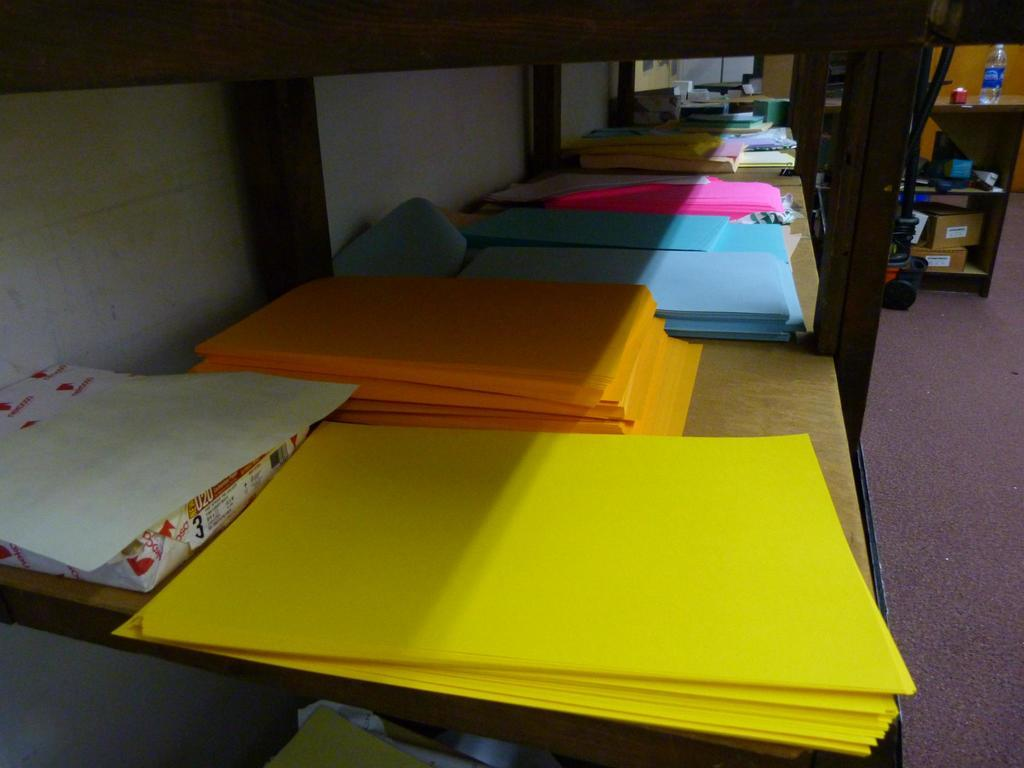What type of items can be seen in the image? There are color papers in the image. Where are the color papers located? The color papers are kept in a shelf. What type of sweater is being worn by the person in the image? There is no person or sweater present in the image; it only features color papers in a shelf. 